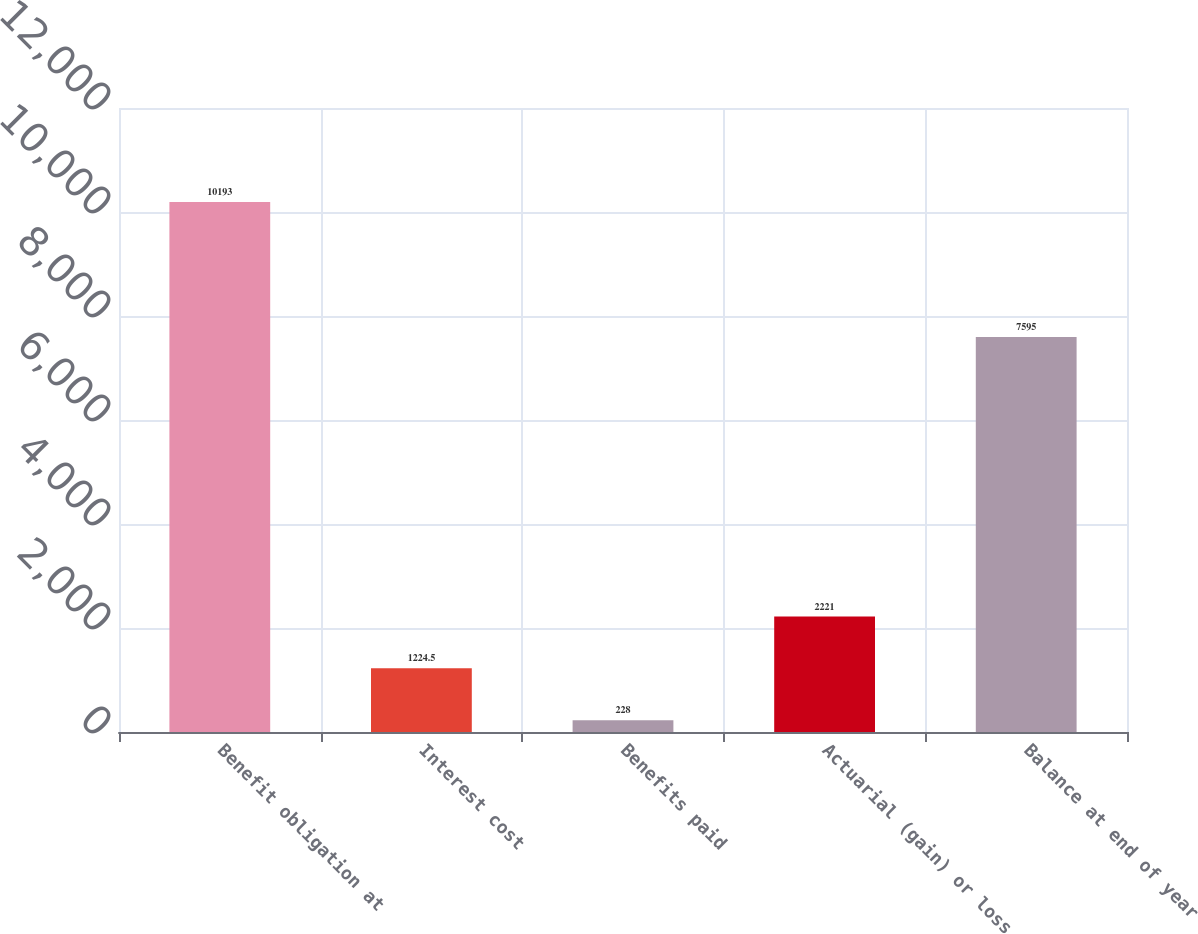Convert chart to OTSL. <chart><loc_0><loc_0><loc_500><loc_500><bar_chart><fcel>Benefit obligation at<fcel>Interest cost<fcel>Benefits paid<fcel>Actuarial (gain) or loss<fcel>Balance at end of year<nl><fcel>10193<fcel>1224.5<fcel>228<fcel>2221<fcel>7595<nl></chart> 